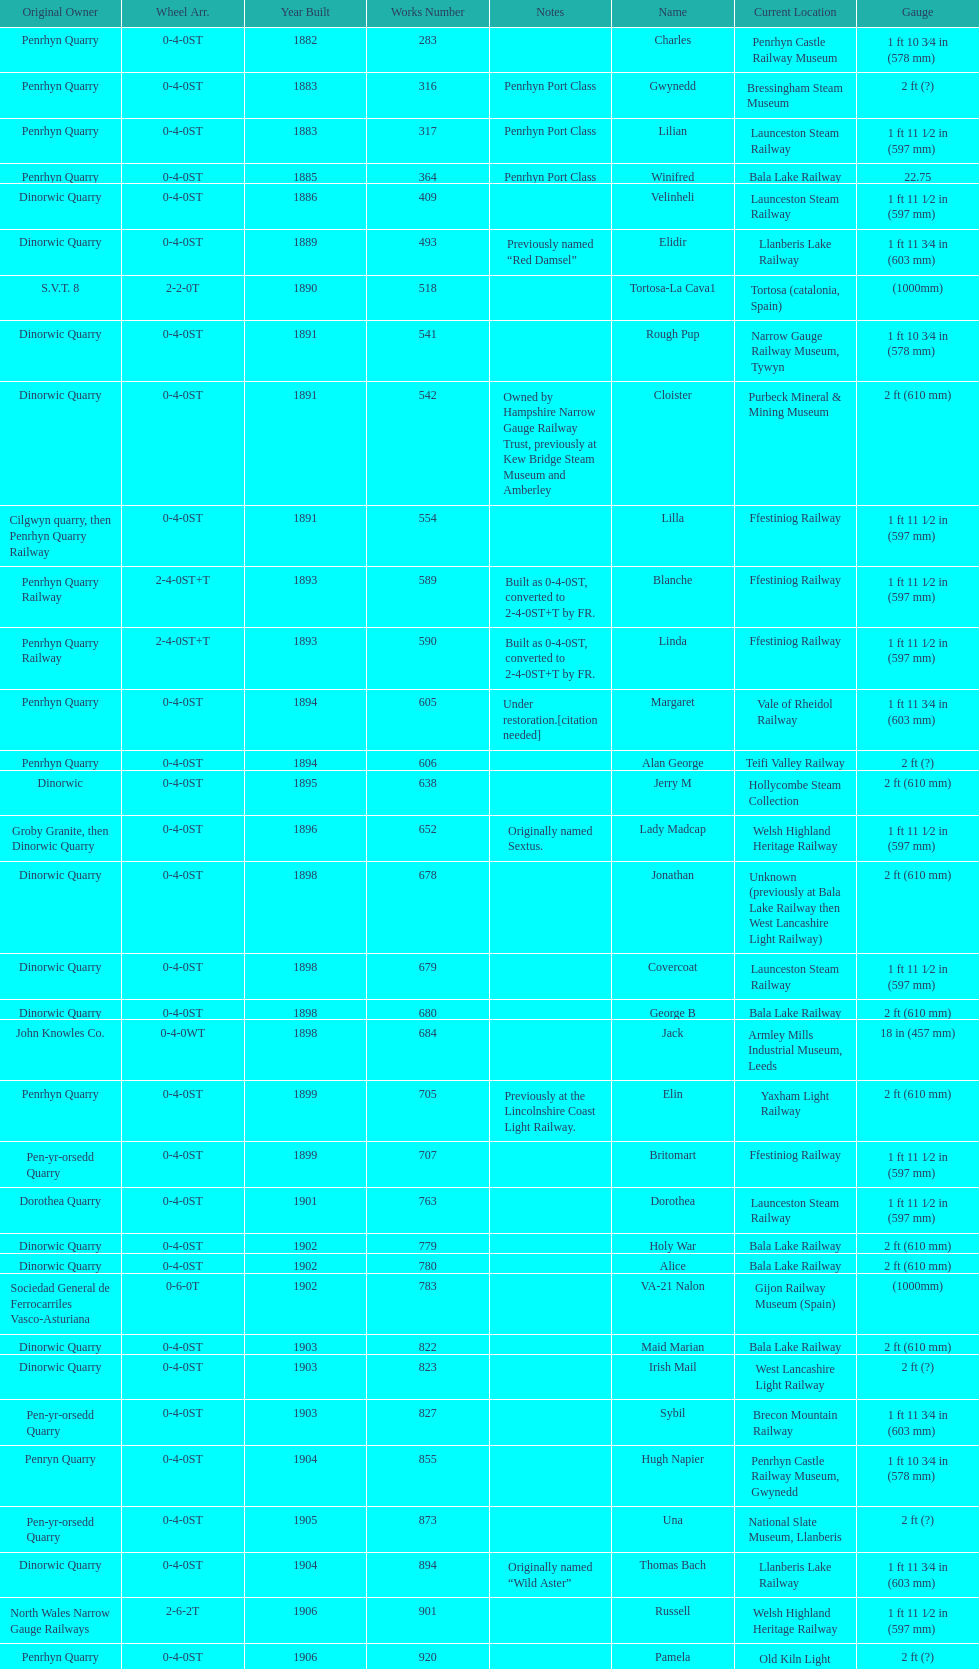Who owned the last locomotive to be built? Trangkil Sugar Mill, Indonesia. 